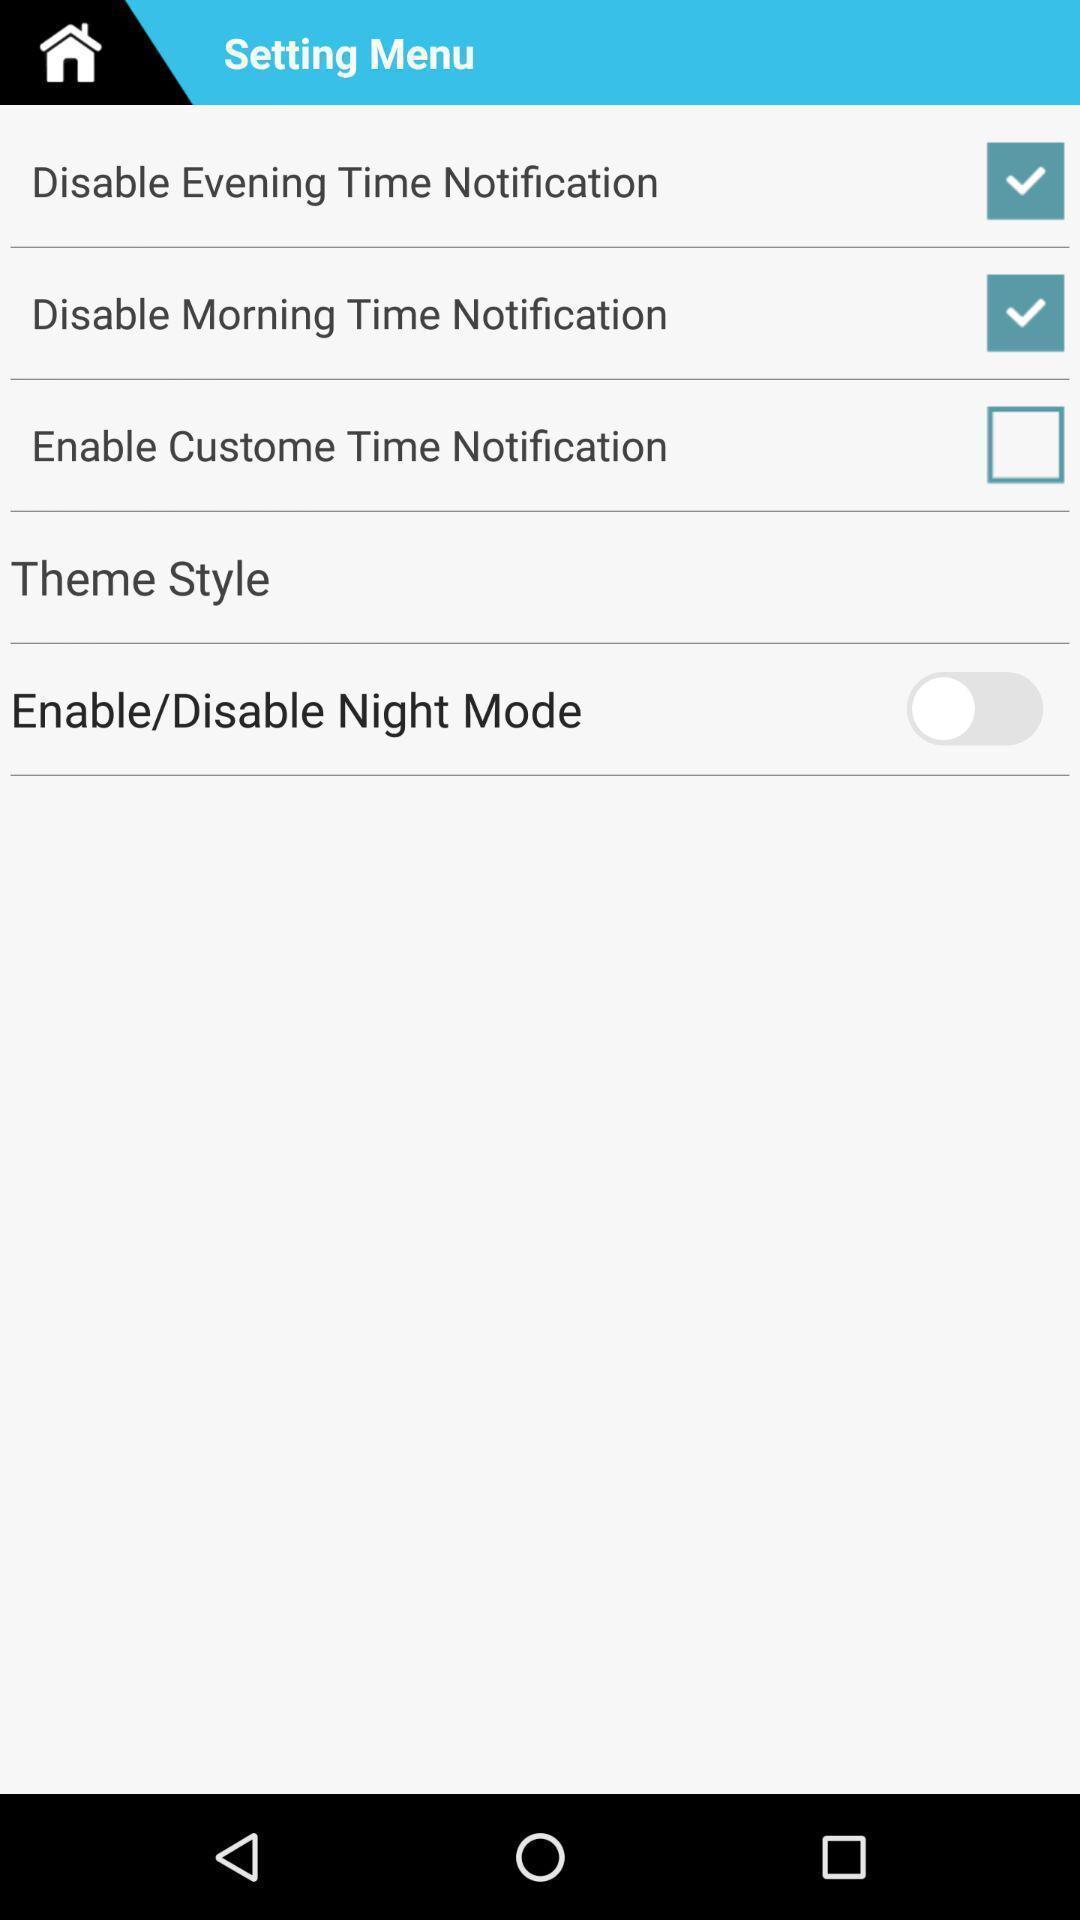Provide a description of this screenshot. Settings menu page with various options. 